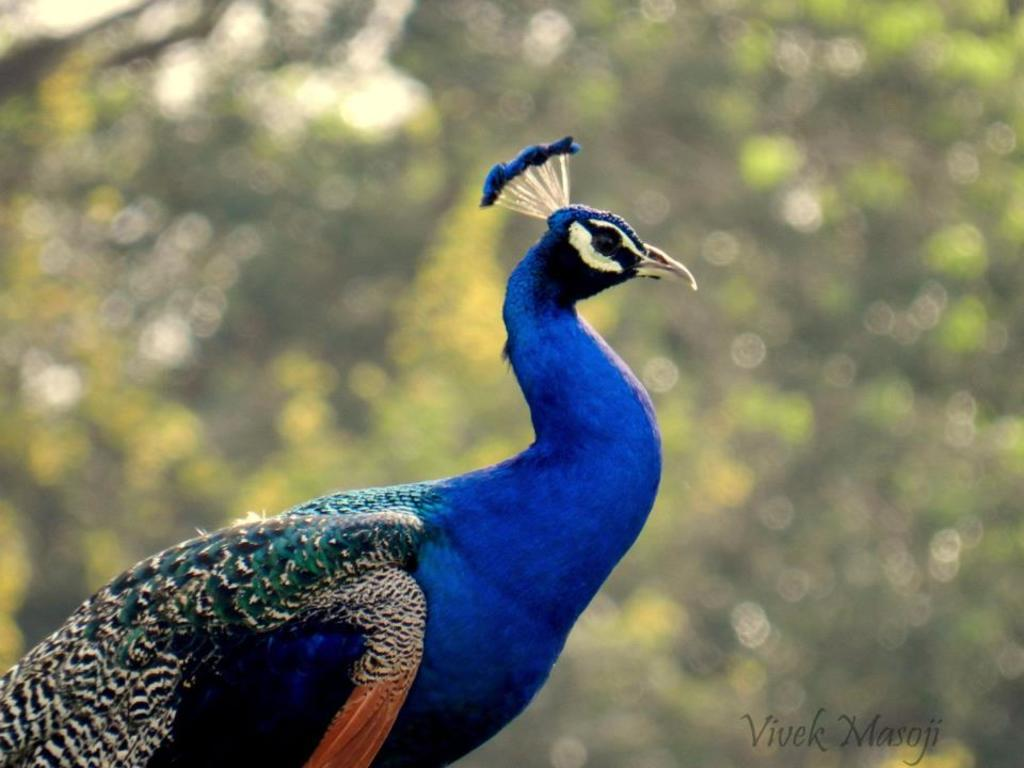What animal is the main subject of the image? There is a peacock in the image. What color is the peacock? The peacock is blue in color. What can be seen in the background of the image? There are trees in the background of the image. How is the background of the image depicted? The background of the image is blurred. What type of coat is the peacock wearing in the image? Peacocks do not wear coats, as they are birds and do not require clothing. 